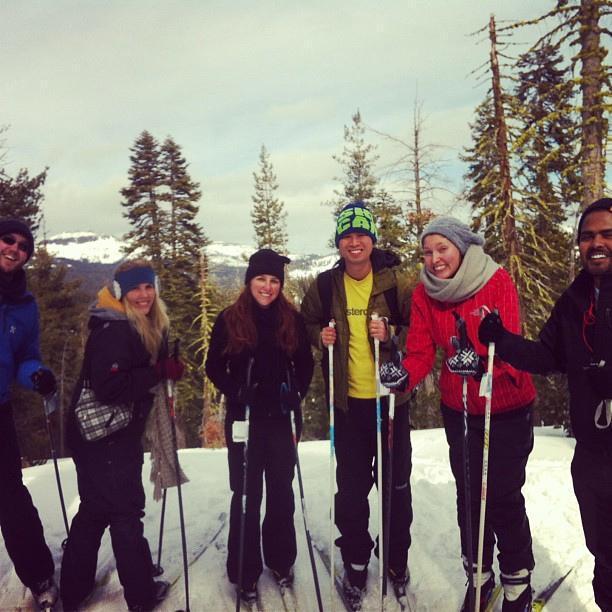How many ladies are there?
Give a very brief answer. 3. How many people are there?
Give a very brief answer. 6. 